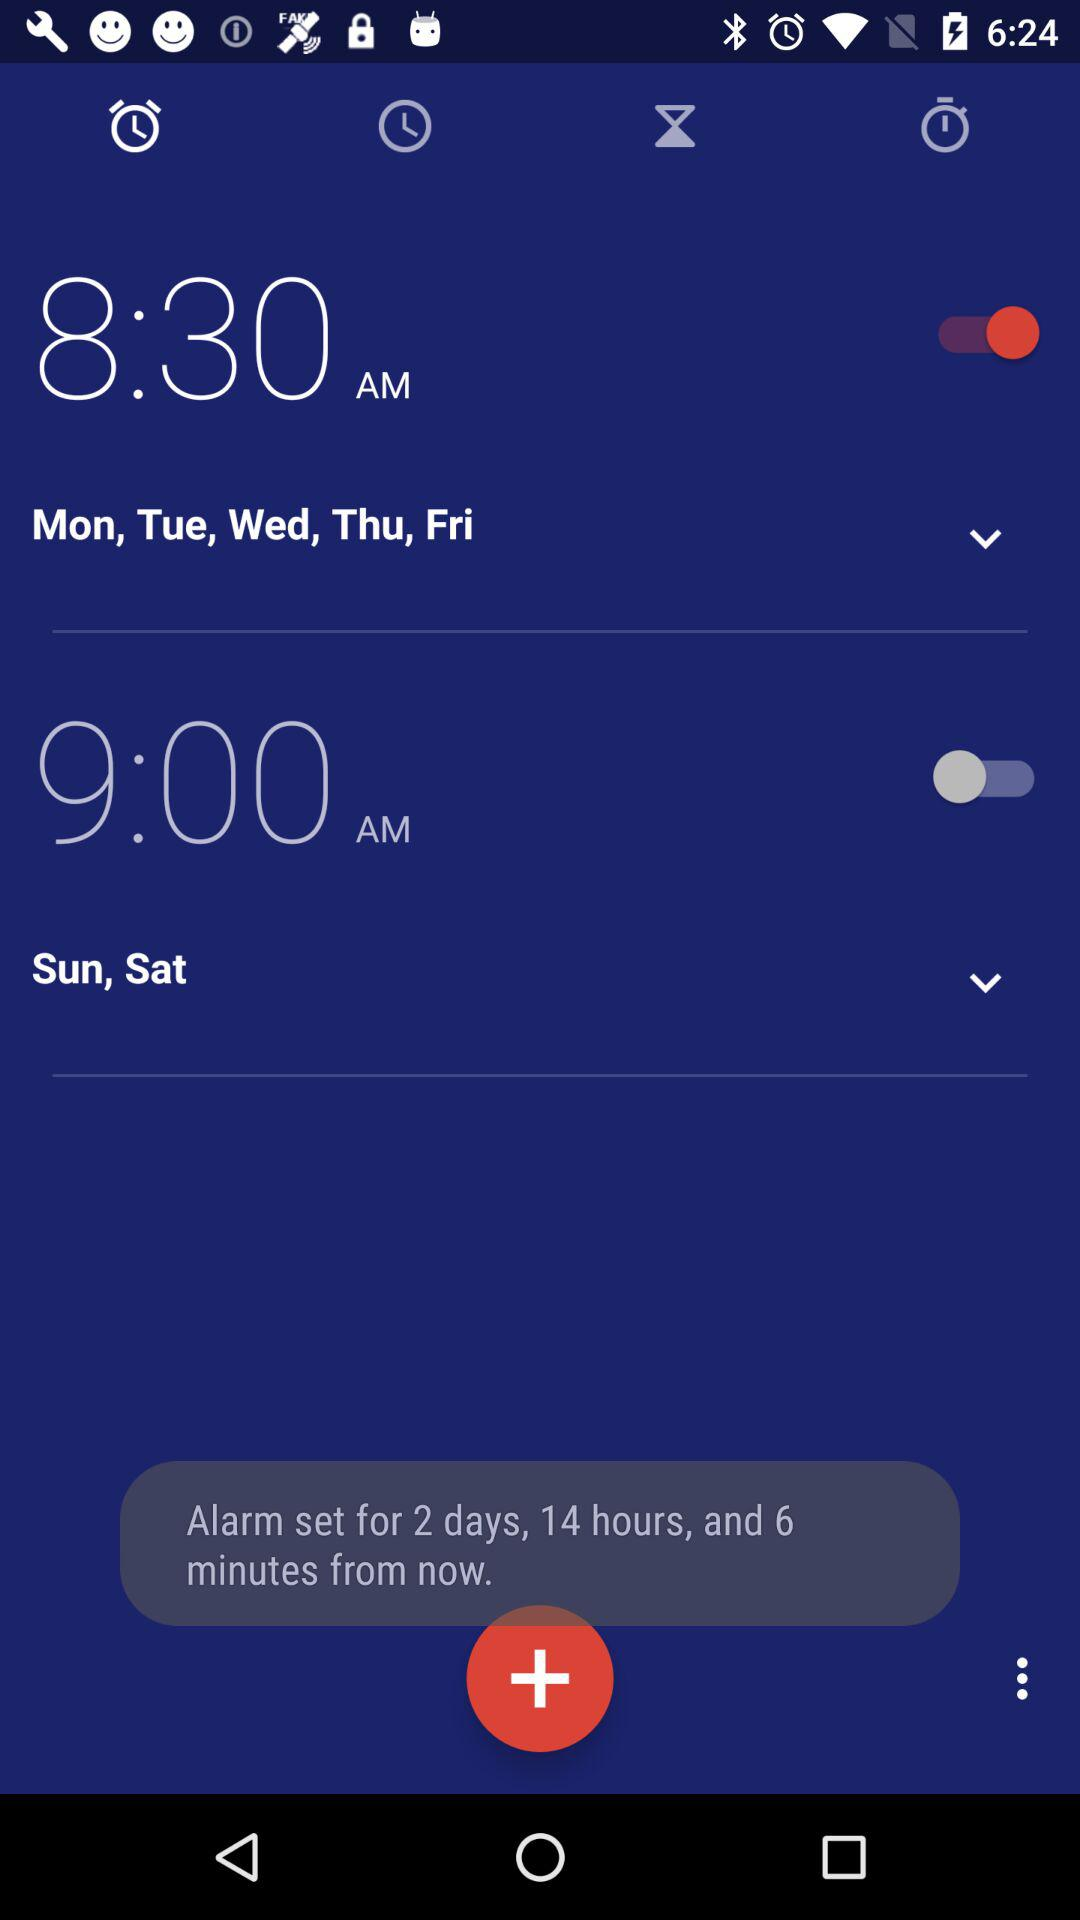Which tab is selected? The selected tab is "Alarm". 